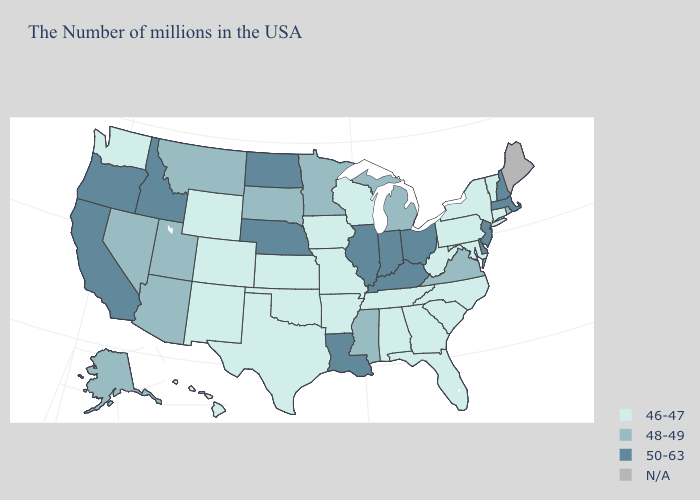Name the states that have a value in the range N/A?
Give a very brief answer. Maine. Name the states that have a value in the range 48-49?
Be succinct. Rhode Island, Virginia, Michigan, Mississippi, Minnesota, South Dakota, Utah, Montana, Arizona, Nevada, Alaska. Among the states that border Georgia , which have the highest value?
Concise answer only. North Carolina, South Carolina, Florida, Alabama, Tennessee. Does Mississippi have the highest value in the USA?
Concise answer only. No. What is the value of Mississippi?
Answer briefly. 48-49. Does Oregon have the highest value in the USA?
Short answer required. Yes. Name the states that have a value in the range 48-49?
Quick response, please. Rhode Island, Virginia, Michigan, Mississippi, Minnesota, South Dakota, Utah, Montana, Arizona, Nevada, Alaska. Does Oklahoma have the lowest value in the USA?
Answer briefly. Yes. What is the lowest value in the USA?
Answer briefly. 46-47. Name the states that have a value in the range 46-47?
Be succinct. Vermont, Connecticut, New York, Maryland, Pennsylvania, North Carolina, South Carolina, West Virginia, Florida, Georgia, Alabama, Tennessee, Wisconsin, Missouri, Arkansas, Iowa, Kansas, Oklahoma, Texas, Wyoming, Colorado, New Mexico, Washington, Hawaii. What is the value of Delaware?
Answer briefly. 50-63. What is the value of North Dakota?
Answer briefly. 50-63. Does Idaho have the highest value in the USA?
Concise answer only. Yes. What is the value of Kansas?
Be succinct. 46-47. What is the value of Indiana?
Write a very short answer. 50-63. 